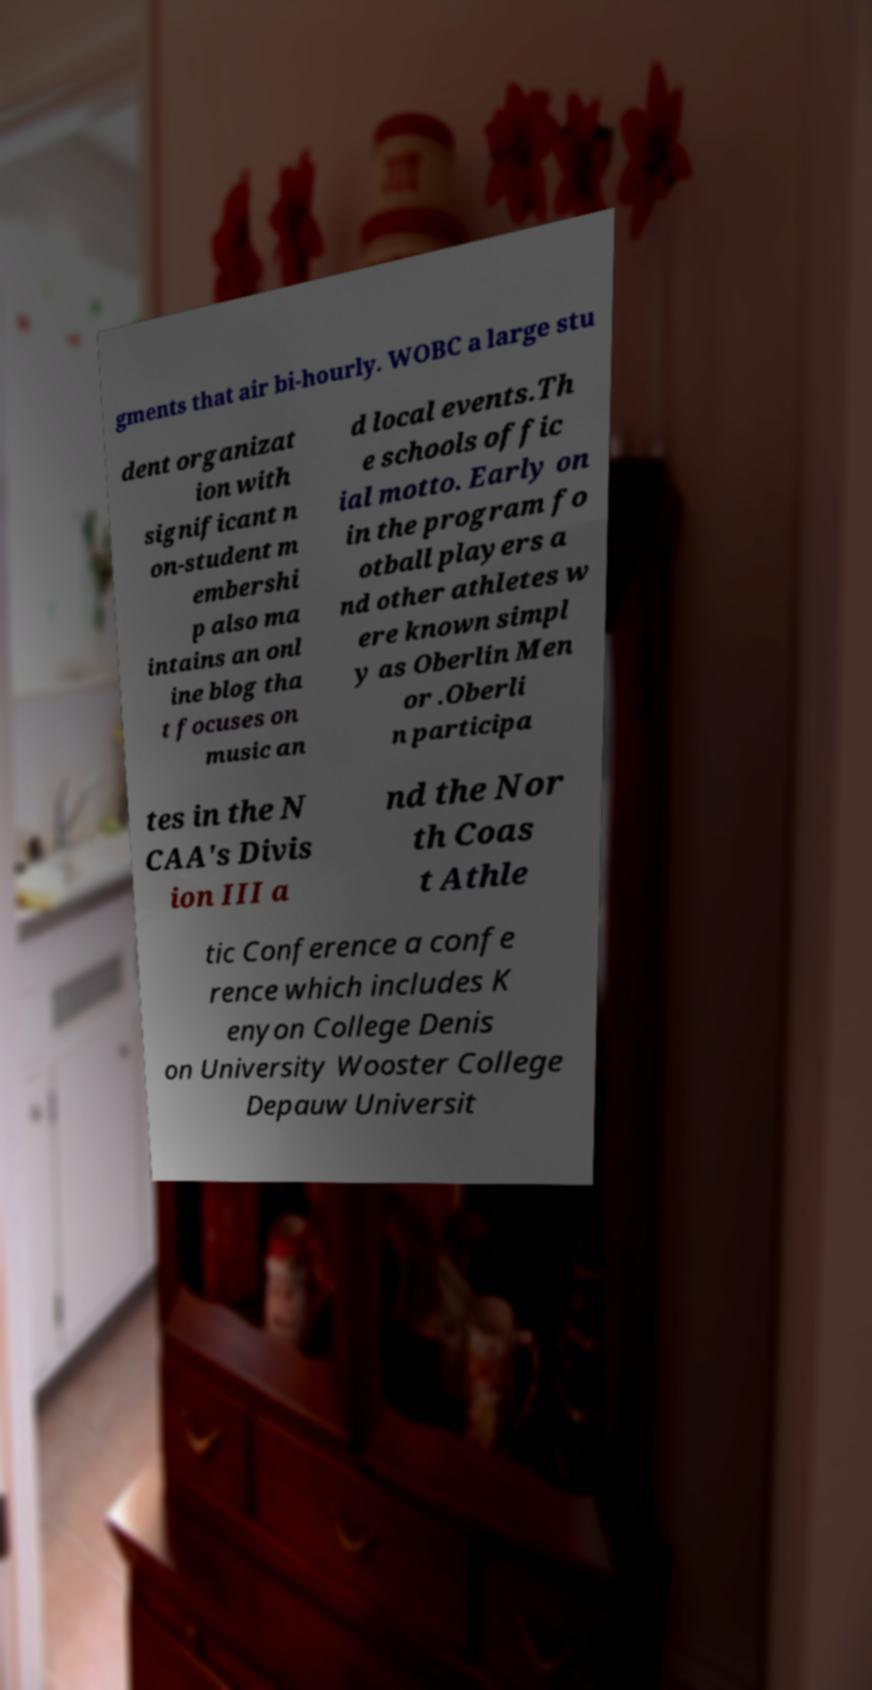What messages or text are displayed in this image? I need them in a readable, typed format. gments that air bi-hourly. WOBC a large stu dent organizat ion with significant n on-student m embershi p also ma intains an onl ine blog tha t focuses on music an d local events.Th e schools offic ial motto. Early on in the program fo otball players a nd other athletes w ere known simpl y as Oberlin Men or .Oberli n participa tes in the N CAA's Divis ion III a nd the Nor th Coas t Athle tic Conference a confe rence which includes K enyon College Denis on University Wooster College Depauw Universit 